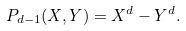<formula> <loc_0><loc_0><loc_500><loc_500>P _ { d - 1 } ( X , Y ) = X ^ { d } - Y ^ { d } .</formula> 